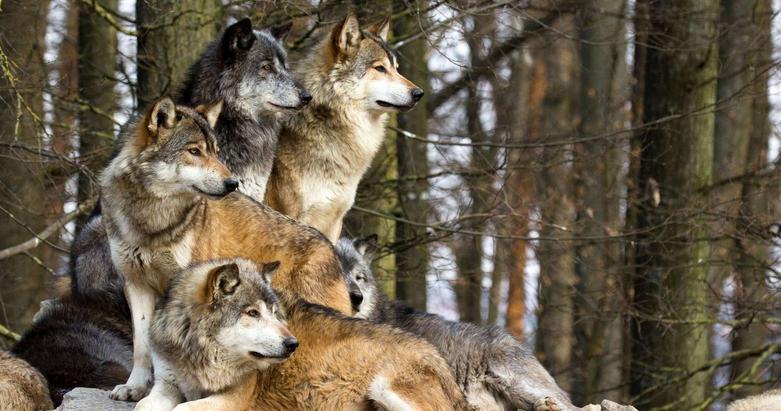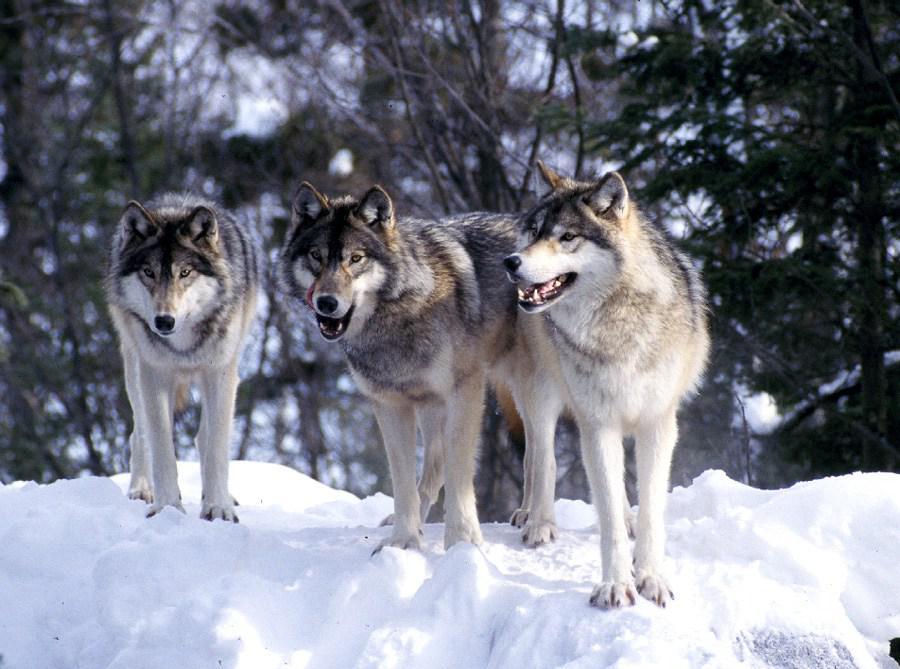The first image is the image on the left, the second image is the image on the right. Analyze the images presented: Is the assertion "An image shows a row of three wolves with heads that are not raised high, and two of the wolves have open mouths." valid? Answer yes or no. Yes. The first image is the image on the left, the second image is the image on the right. Analyze the images presented: Is the assertion "There are exactly three wolves standing next to each-other in the image on the left." valid? Answer yes or no. No. 